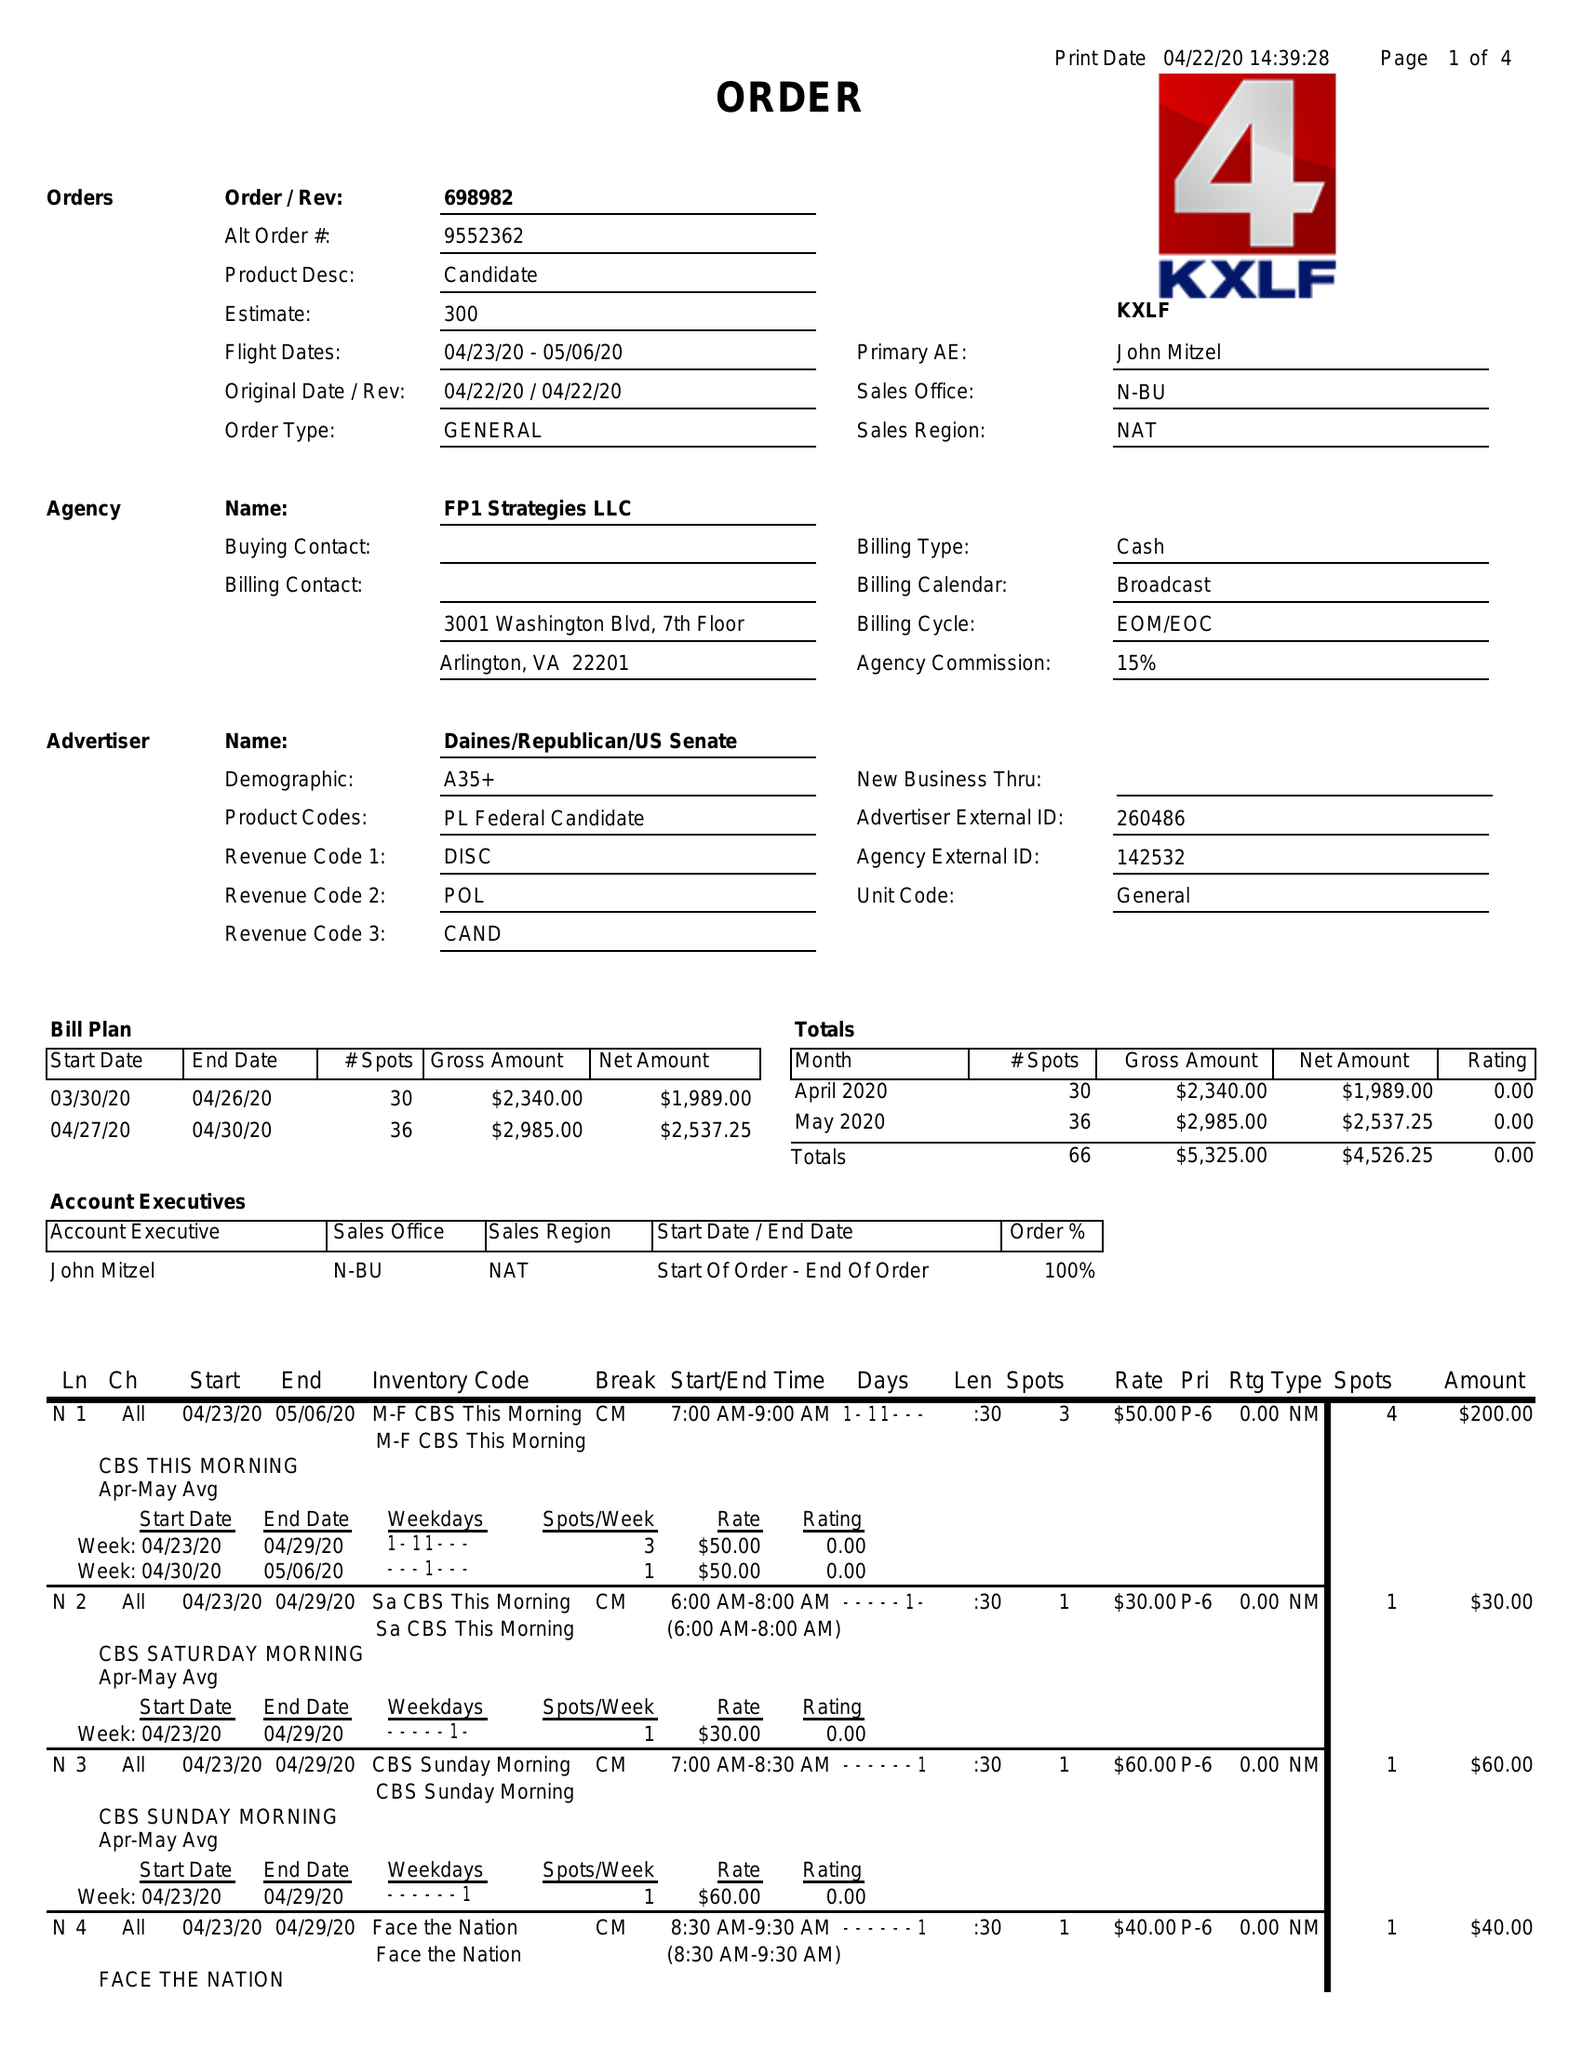What is the value for the advertiser?
Answer the question using a single word or phrase. DAINES/REPUBLICAN/USSENATE 